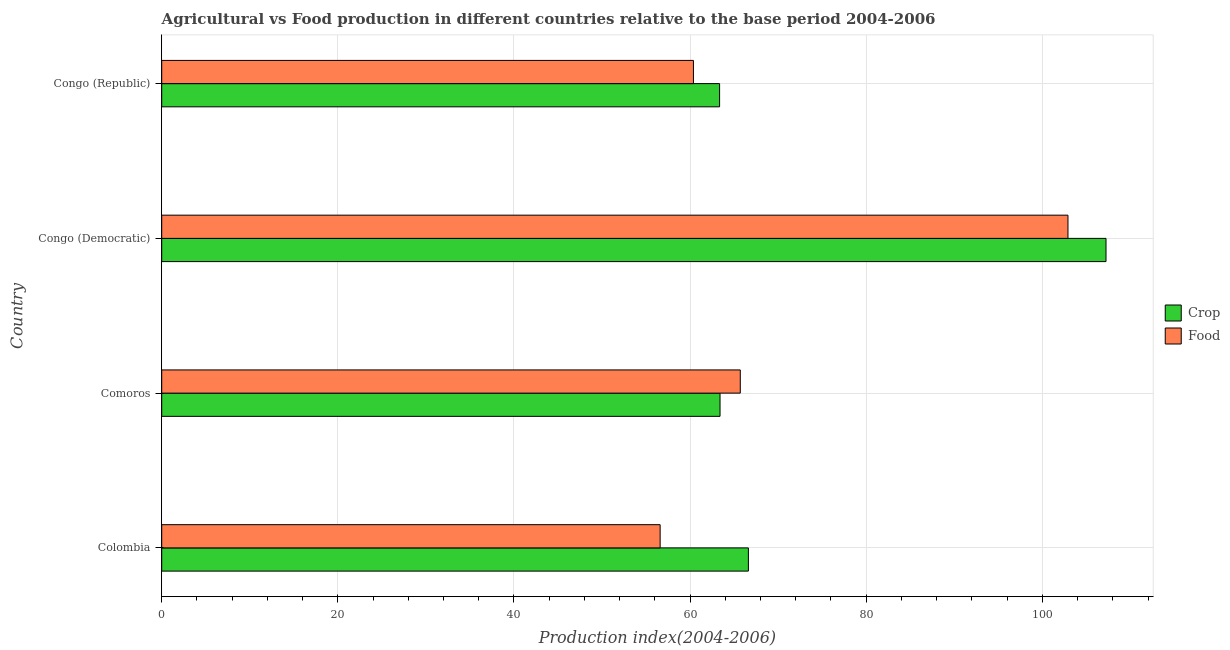How many groups of bars are there?
Ensure brevity in your answer.  4. Are the number of bars on each tick of the Y-axis equal?
Ensure brevity in your answer.  Yes. How many bars are there on the 3rd tick from the top?
Your response must be concise. 2. What is the label of the 4th group of bars from the top?
Provide a short and direct response. Colombia. In how many cases, is the number of bars for a given country not equal to the number of legend labels?
Your response must be concise. 0. What is the food production index in Congo (Democratic)?
Your answer should be compact. 102.91. Across all countries, what is the maximum food production index?
Keep it short and to the point. 102.91. Across all countries, what is the minimum crop production index?
Keep it short and to the point. 63.35. In which country was the crop production index maximum?
Offer a very short reply. Congo (Democratic). In which country was the food production index minimum?
Your answer should be very brief. Colombia. What is the total food production index in the graph?
Your answer should be compact. 285.59. What is the difference between the food production index in Congo (Democratic) and that in Congo (Republic)?
Offer a very short reply. 42.53. What is the difference between the food production index in Congo (Democratic) and the crop production index in Congo (Republic)?
Your response must be concise. 39.56. What is the average crop production index per country?
Keep it short and to the point. 75.15. What is the difference between the crop production index and food production index in Colombia?
Offer a very short reply. 10.02. In how many countries, is the crop production index greater than 72 ?
Ensure brevity in your answer.  1. What is the ratio of the crop production index in Colombia to that in Congo (Republic)?
Your answer should be compact. 1.05. Is the difference between the food production index in Congo (Democratic) and Congo (Republic) greater than the difference between the crop production index in Congo (Democratic) and Congo (Republic)?
Give a very brief answer. No. What is the difference between the highest and the second highest food production index?
Make the answer very short. 37.21. What is the difference between the highest and the lowest crop production index?
Give a very brief answer. 43.88. Is the sum of the crop production index in Colombia and Congo (Republic) greater than the maximum food production index across all countries?
Provide a succinct answer. Yes. What does the 2nd bar from the top in Colombia represents?
Ensure brevity in your answer.  Crop. What does the 2nd bar from the bottom in Colombia represents?
Your answer should be compact. Food. How many bars are there?
Provide a succinct answer. 8. What is the difference between two consecutive major ticks on the X-axis?
Offer a terse response. 20. Are the values on the major ticks of X-axis written in scientific E-notation?
Your answer should be very brief. No. Does the graph contain any zero values?
Make the answer very short. No. Where does the legend appear in the graph?
Ensure brevity in your answer.  Center right. How many legend labels are there?
Your response must be concise. 2. How are the legend labels stacked?
Provide a succinct answer. Vertical. What is the title of the graph?
Your answer should be compact. Agricultural vs Food production in different countries relative to the base period 2004-2006. Does "Nonresident" appear as one of the legend labels in the graph?
Provide a short and direct response. No. What is the label or title of the X-axis?
Your answer should be compact. Production index(2004-2006). What is the Production index(2004-2006) in Crop in Colombia?
Offer a very short reply. 66.62. What is the Production index(2004-2006) of Food in Colombia?
Provide a succinct answer. 56.6. What is the Production index(2004-2006) in Crop in Comoros?
Ensure brevity in your answer.  63.4. What is the Production index(2004-2006) in Food in Comoros?
Your answer should be very brief. 65.7. What is the Production index(2004-2006) of Crop in Congo (Democratic)?
Provide a short and direct response. 107.23. What is the Production index(2004-2006) of Food in Congo (Democratic)?
Provide a succinct answer. 102.91. What is the Production index(2004-2006) in Crop in Congo (Republic)?
Your answer should be compact. 63.35. What is the Production index(2004-2006) in Food in Congo (Republic)?
Offer a very short reply. 60.38. Across all countries, what is the maximum Production index(2004-2006) in Crop?
Your answer should be very brief. 107.23. Across all countries, what is the maximum Production index(2004-2006) in Food?
Provide a succinct answer. 102.91. Across all countries, what is the minimum Production index(2004-2006) of Crop?
Your answer should be very brief. 63.35. Across all countries, what is the minimum Production index(2004-2006) in Food?
Your answer should be very brief. 56.6. What is the total Production index(2004-2006) in Crop in the graph?
Offer a terse response. 300.6. What is the total Production index(2004-2006) of Food in the graph?
Your answer should be compact. 285.59. What is the difference between the Production index(2004-2006) of Crop in Colombia and that in Comoros?
Your response must be concise. 3.22. What is the difference between the Production index(2004-2006) of Crop in Colombia and that in Congo (Democratic)?
Provide a succinct answer. -40.61. What is the difference between the Production index(2004-2006) in Food in Colombia and that in Congo (Democratic)?
Ensure brevity in your answer.  -46.31. What is the difference between the Production index(2004-2006) in Crop in Colombia and that in Congo (Republic)?
Your answer should be compact. 3.27. What is the difference between the Production index(2004-2006) in Food in Colombia and that in Congo (Republic)?
Give a very brief answer. -3.78. What is the difference between the Production index(2004-2006) in Crop in Comoros and that in Congo (Democratic)?
Your answer should be compact. -43.83. What is the difference between the Production index(2004-2006) of Food in Comoros and that in Congo (Democratic)?
Offer a terse response. -37.21. What is the difference between the Production index(2004-2006) of Crop in Comoros and that in Congo (Republic)?
Your response must be concise. 0.05. What is the difference between the Production index(2004-2006) in Food in Comoros and that in Congo (Republic)?
Give a very brief answer. 5.32. What is the difference between the Production index(2004-2006) in Crop in Congo (Democratic) and that in Congo (Republic)?
Provide a succinct answer. 43.88. What is the difference between the Production index(2004-2006) of Food in Congo (Democratic) and that in Congo (Republic)?
Ensure brevity in your answer.  42.53. What is the difference between the Production index(2004-2006) in Crop in Colombia and the Production index(2004-2006) in Food in Comoros?
Your answer should be compact. 0.92. What is the difference between the Production index(2004-2006) in Crop in Colombia and the Production index(2004-2006) in Food in Congo (Democratic)?
Offer a terse response. -36.29. What is the difference between the Production index(2004-2006) in Crop in Colombia and the Production index(2004-2006) in Food in Congo (Republic)?
Provide a short and direct response. 6.24. What is the difference between the Production index(2004-2006) of Crop in Comoros and the Production index(2004-2006) of Food in Congo (Democratic)?
Give a very brief answer. -39.51. What is the difference between the Production index(2004-2006) of Crop in Comoros and the Production index(2004-2006) of Food in Congo (Republic)?
Your response must be concise. 3.02. What is the difference between the Production index(2004-2006) in Crop in Congo (Democratic) and the Production index(2004-2006) in Food in Congo (Republic)?
Provide a short and direct response. 46.85. What is the average Production index(2004-2006) of Crop per country?
Offer a terse response. 75.15. What is the average Production index(2004-2006) of Food per country?
Offer a very short reply. 71.4. What is the difference between the Production index(2004-2006) of Crop and Production index(2004-2006) of Food in Colombia?
Provide a short and direct response. 10.02. What is the difference between the Production index(2004-2006) in Crop and Production index(2004-2006) in Food in Comoros?
Your answer should be very brief. -2.3. What is the difference between the Production index(2004-2006) in Crop and Production index(2004-2006) in Food in Congo (Democratic)?
Make the answer very short. 4.32. What is the difference between the Production index(2004-2006) in Crop and Production index(2004-2006) in Food in Congo (Republic)?
Give a very brief answer. 2.97. What is the ratio of the Production index(2004-2006) of Crop in Colombia to that in Comoros?
Offer a terse response. 1.05. What is the ratio of the Production index(2004-2006) in Food in Colombia to that in Comoros?
Your answer should be compact. 0.86. What is the ratio of the Production index(2004-2006) in Crop in Colombia to that in Congo (Democratic)?
Provide a short and direct response. 0.62. What is the ratio of the Production index(2004-2006) in Food in Colombia to that in Congo (Democratic)?
Make the answer very short. 0.55. What is the ratio of the Production index(2004-2006) of Crop in Colombia to that in Congo (Republic)?
Offer a terse response. 1.05. What is the ratio of the Production index(2004-2006) of Food in Colombia to that in Congo (Republic)?
Keep it short and to the point. 0.94. What is the ratio of the Production index(2004-2006) in Crop in Comoros to that in Congo (Democratic)?
Provide a succinct answer. 0.59. What is the ratio of the Production index(2004-2006) of Food in Comoros to that in Congo (Democratic)?
Provide a short and direct response. 0.64. What is the ratio of the Production index(2004-2006) of Food in Comoros to that in Congo (Republic)?
Your answer should be compact. 1.09. What is the ratio of the Production index(2004-2006) of Crop in Congo (Democratic) to that in Congo (Republic)?
Your response must be concise. 1.69. What is the ratio of the Production index(2004-2006) in Food in Congo (Democratic) to that in Congo (Republic)?
Give a very brief answer. 1.7. What is the difference between the highest and the second highest Production index(2004-2006) in Crop?
Offer a very short reply. 40.61. What is the difference between the highest and the second highest Production index(2004-2006) in Food?
Ensure brevity in your answer.  37.21. What is the difference between the highest and the lowest Production index(2004-2006) in Crop?
Make the answer very short. 43.88. What is the difference between the highest and the lowest Production index(2004-2006) of Food?
Offer a very short reply. 46.31. 